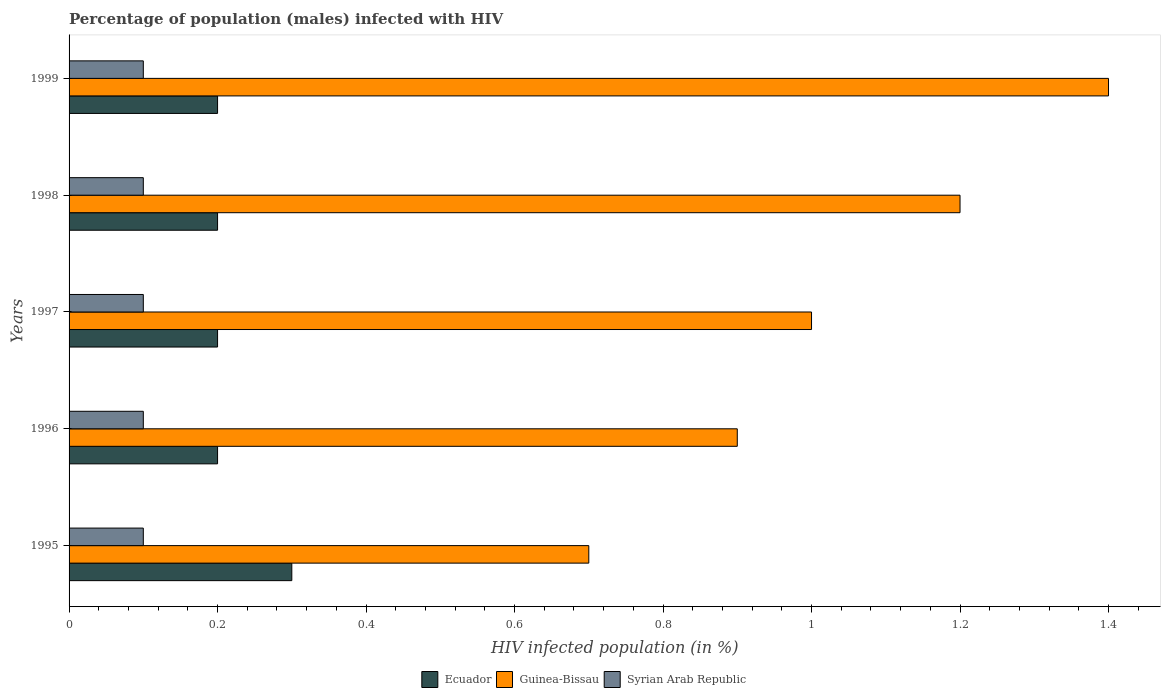How many different coloured bars are there?
Your answer should be compact. 3. Are the number of bars per tick equal to the number of legend labels?
Offer a terse response. Yes. What is the label of the 5th group of bars from the top?
Ensure brevity in your answer.  1995. What is the percentage of HIV infected male population in Guinea-Bissau in 1995?
Keep it short and to the point. 0.7. Across all years, what is the maximum percentage of HIV infected male population in Guinea-Bissau?
Ensure brevity in your answer.  1.4. Across all years, what is the minimum percentage of HIV infected male population in Guinea-Bissau?
Ensure brevity in your answer.  0.7. In which year was the percentage of HIV infected male population in Syrian Arab Republic maximum?
Give a very brief answer. 1995. What is the total percentage of HIV infected male population in Ecuador in the graph?
Offer a very short reply. 1.1. What is the difference between the percentage of HIV infected male population in Ecuador in 1995 and that in 1996?
Offer a terse response. 0.1. What is the difference between the percentage of HIV infected male population in Syrian Arab Republic in 1997 and the percentage of HIV infected male population in Guinea-Bissau in 1999?
Your response must be concise. -1.3. In the year 1996, what is the difference between the percentage of HIV infected male population in Guinea-Bissau and percentage of HIV infected male population in Ecuador?
Your answer should be very brief. 0.7. Is the percentage of HIV infected male population in Ecuador in 1996 less than that in 1998?
Make the answer very short. No. Is the difference between the percentage of HIV infected male population in Guinea-Bissau in 1997 and 1998 greater than the difference between the percentage of HIV infected male population in Ecuador in 1997 and 1998?
Provide a succinct answer. No. What is the difference between the highest and the second highest percentage of HIV infected male population in Guinea-Bissau?
Offer a very short reply. 0.2. In how many years, is the percentage of HIV infected male population in Guinea-Bissau greater than the average percentage of HIV infected male population in Guinea-Bissau taken over all years?
Your answer should be very brief. 2. Is the sum of the percentage of HIV infected male population in Syrian Arab Republic in 1998 and 1999 greater than the maximum percentage of HIV infected male population in Guinea-Bissau across all years?
Your answer should be compact. No. What does the 1st bar from the top in 1995 represents?
Make the answer very short. Syrian Arab Republic. What does the 2nd bar from the bottom in 1995 represents?
Your answer should be very brief. Guinea-Bissau. Are all the bars in the graph horizontal?
Your answer should be compact. Yes. What is the difference between two consecutive major ticks on the X-axis?
Your answer should be compact. 0.2. Does the graph contain grids?
Provide a short and direct response. No. Where does the legend appear in the graph?
Your response must be concise. Bottom center. How many legend labels are there?
Your response must be concise. 3. What is the title of the graph?
Give a very brief answer. Percentage of population (males) infected with HIV. Does "Samoa" appear as one of the legend labels in the graph?
Ensure brevity in your answer.  No. What is the label or title of the X-axis?
Provide a short and direct response. HIV infected population (in %). What is the label or title of the Y-axis?
Your response must be concise. Years. What is the HIV infected population (in %) of Guinea-Bissau in 1995?
Provide a short and direct response. 0.7. What is the HIV infected population (in %) in Syrian Arab Republic in 1995?
Your response must be concise. 0.1. What is the HIV infected population (in %) of Guinea-Bissau in 1996?
Offer a very short reply. 0.9. What is the HIV infected population (in %) in Syrian Arab Republic in 1996?
Ensure brevity in your answer.  0.1. What is the HIV infected population (in %) of Guinea-Bissau in 1997?
Keep it short and to the point. 1. What is the HIV infected population (in %) in Syrian Arab Republic in 1997?
Offer a very short reply. 0.1. What is the HIV infected population (in %) in Syrian Arab Republic in 1998?
Your answer should be very brief. 0.1. What is the HIV infected population (in %) in Guinea-Bissau in 1999?
Your answer should be compact. 1.4. Across all years, what is the maximum HIV infected population (in %) in Ecuador?
Offer a terse response. 0.3. Across all years, what is the maximum HIV infected population (in %) in Syrian Arab Republic?
Your response must be concise. 0.1. Across all years, what is the minimum HIV infected population (in %) in Syrian Arab Republic?
Offer a terse response. 0.1. What is the total HIV infected population (in %) in Ecuador in the graph?
Provide a short and direct response. 1.1. What is the total HIV infected population (in %) in Guinea-Bissau in the graph?
Your response must be concise. 5.2. What is the difference between the HIV infected population (in %) of Ecuador in 1995 and that in 1997?
Make the answer very short. 0.1. What is the difference between the HIV infected population (in %) in Guinea-Bissau in 1995 and that in 1997?
Offer a very short reply. -0.3. What is the difference between the HIV infected population (in %) of Syrian Arab Republic in 1995 and that in 1997?
Your answer should be compact. 0. What is the difference between the HIV infected population (in %) of Ecuador in 1995 and that in 1998?
Provide a succinct answer. 0.1. What is the difference between the HIV infected population (in %) in Guinea-Bissau in 1995 and that in 1998?
Provide a short and direct response. -0.5. What is the difference between the HIV infected population (in %) of Ecuador in 1995 and that in 1999?
Give a very brief answer. 0.1. What is the difference between the HIV infected population (in %) of Syrian Arab Republic in 1996 and that in 1997?
Offer a very short reply. 0. What is the difference between the HIV infected population (in %) of Ecuador in 1996 and that in 1999?
Your answer should be compact. 0. What is the difference between the HIV infected population (in %) in Ecuador in 1997 and that in 1998?
Your answer should be compact. 0. What is the difference between the HIV infected population (in %) of Syrian Arab Republic in 1997 and that in 1998?
Your answer should be compact. 0. What is the difference between the HIV infected population (in %) of Ecuador in 1997 and that in 1999?
Give a very brief answer. 0. What is the difference between the HIV infected population (in %) of Guinea-Bissau in 1998 and that in 1999?
Ensure brevity in your answer.  -0.2. What is the difference between the HIV infected population (in %) in Ecuador in 1995 and the HIV infected population (in %) in Guinea-Bissau in 1996?
Provide a succinct answer. -0.6. What is the difference between the HIV infected population (in %) of Ecuador in 1995 and the HIV infected population (in %) of Syrian Arab Republic in 1996?
Provide a succinct answer. 0.2. What is the difference between the HIV infected population (in %) of Guinea-Bissau in 1995 and the HIV infected population (in %) of Syrian Arab Republic in 1997?
Keep it short and to the point. 0.6. What is the difference between the HIV infected population (in %) in Ecuador in 1995 and the HIV infected population (in %) in Guinea-Bissau in 1998?
Give a very brief answer. -0.9. What is the difference between the HIV infected population (in %) in Guinea-Bissau in 1995 and the HIV infected population (in %) in Syrian Arab Republic in 1998?
Provide a short and direct response. 0.6. What is the difference between the HIV infected population (in %) in Ecuador in 1995 and the HIV infected population (in %) in Guinea-Bissau in 1999?
Provide a succinct answer. -1.1. What is the difference between the HIV infected population (in %) in Ecuador in 1996 and the HIV infected population (in %) in Syrian Arab Republic in 1997?
Your answer should be compact. 0.1. What is the difference between the HIV infected population (in %) in Guinea-Bissau in 1996 and the HIV infected population (in %) in Syrian Arab Republic in 1998?
Offer a terse response. 0.8. What is the difference between the HIV infected population (in %) of Ecuador in 1996 and the HIV infected population (in %) of Guinea-Bissau in 1999?
Make the answer very short. -1.2. What is the difference between the HIV infected population (in %) of Guinea-Bissau in 1996 and the HIV infected population (in %) of Syrian Arab Republic in 1999?
Your response must be concise. 0.8. What is the difference between the HIV infected population (in %) of Guinea-Bissau in 1997 and the HIV infected population (in %) of Syrian Arab Republic in 1998?
Your response must be concise. 0.9. What is the difference between the HIV infected population (in %) of Guinea-Bissau in 1998 and the HIV infected population (in %) of Syrian Arab Republic in 1999?
Provide a succinct answer. 1.1. What is the average HIV infected population (in %) in Ecuador per year?
Offer a terse response. 0.22. What is the average HIV infected population (in %) in Guinea-Bissau per year?
Ensure brevity in your answer.  1.04. In the year 1995, what is the difference between the HIV infected population (in %) in Guinea-Bissau and HIV infected population (in %) in Syrian Arab Republic?
Keep it short and to the point. 0.6. In the year 1996, what is the difference between the HIV infected population (in %) of Ecuador and HIV infected population (in %) of Guinea-Bissau?
Your answer should be compact. -0.7. In the year 1996, what is the difference between the HIV infected population (in %) of Ecuador and HIV infected population (in %) of Syrian Arab Republic?
Provide a short and direct response. 0.1. In the year 1997, what is the difference between the HIV infected population (in %) of Ecuador and HIV infected population (in %) of Guinea-Bissau?
Your response must be concise. -0.8. In the year 1998, what is the difference between the HIV infected population (in %) in Ecuador and HIV infected population (in %) in Syrian Arab Republic?
Ensure brevity in your answer.  0.1. In the year 1999, what is the difference between the HIV infected population (in %) of Ecuador and HIV infected population (in %) of Guinea-Bissau?
Your response must be concise. -1.2. What is the ratio of the HIV infected population (in %) of Syrian Arab Republic in 1995 to that in 1996?
Your response must be concise. 1. What is the ratio of the HIV infected population (in %) in Guinea-Bissau in 1995 to that in 1997?
Provide a succinct answer. 0.7. What is the ratio of the HIV infected population (in %) of Guinea-Bissau in 1995 to that in 1998?
Give a very brief answer. 0.58. What is the ratio of the HIV infected population (in %) in Ecuador in 1995 to that in 1999?
Keep it short and to the point. 1.5. What is the ratio of the HIV infected population (in %) in Guinea-Bissau in 1996 to that in 1997?
Your response must be concise. 0.9. What is the ratio of the HIV infected population (in %) in Syrian Arab Republic in 1996 to that in 1997?
Keep it short and to the point. 1. What is the ratio of the HIV infected population (in %) of Guinea-Bissau in 1996 to that in 1998?
Ensure brevity in your answer.  0.75. What is the ratio of the HIV infected population (in %) in Guinea-Bissau in 1996 to that in 1999?
Your response must be concise. 0.64. What is the ratio of the HIV infected population (in %) of Guinea-Bissau in 1997 to that in 1998?
Your answer should be very brief. 0.83. What is the ratio of the HIV infected population (in %) of Syrian Arab Republic in 1997 to that in 1998?
Give a very brief answer. 1. What is the ratio of the HIV infected population (in %) of Ecuador in 1997 to that in 1999?
Your answer should be very brief. 1. What is the ratio of the HIV infected population (in %) in Ecuador in 1998 to that in 1999?
Provide a succinct answer. 1. What is the ratio of the HIV infected population (in %) of Guinea-Bissau in 1998 to that in 1999?
Make the answer very short. 0.86. What is the ratio of the HIV infected population (in %) of Syrian Arab Republic in 1998 to that in 1999?
Offer a terse response. 1. What is the difference between the highest and the second highest HIV infected population (in %) of Ecuador?
Offer a very short reply. 0.1. What is the difference between the highest and the second highest HIV infected population (in %) of Guinea-Bissau?
Keep it short and to the point. 0.2. What is the difference between the highest and the second highest HIV infected population (in %) of Syrian Arab Republic?
Ensure brevity in your answer.  0. What is the difference between the highest and the lowest HIV infected population (in %) in Syrian Arab Republic?
Your response must be concise. 0. 